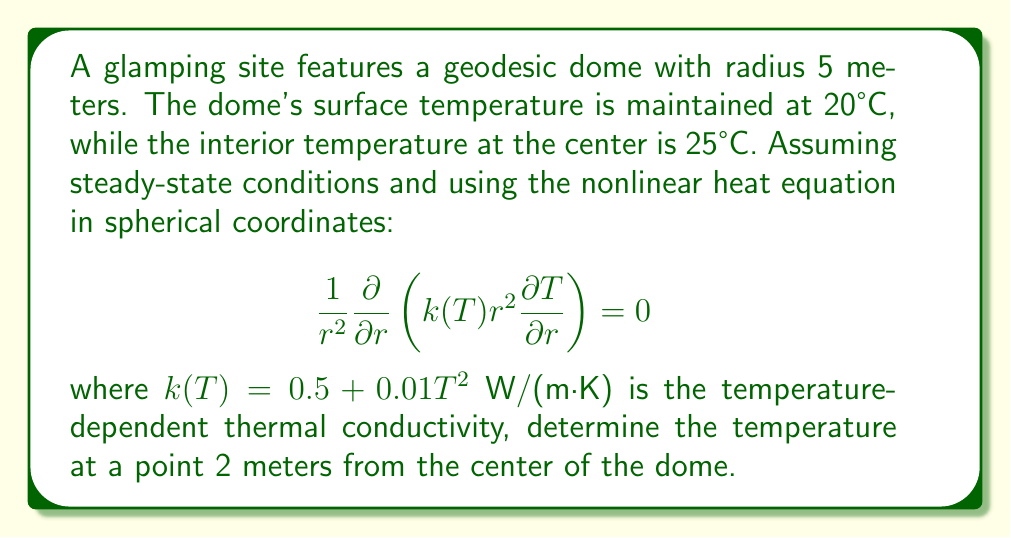Solve this math problem. To solve this problem, we'll follow these steps:

1) The nonlinear heat equation in steady-state spherical coordinates is:

   $$\frac{1}{r^2}\frac{\partial}{\partial r}\left(k(T)r^2\frac{\partial T}{\partial r}\right) = 0$$

2) Expanding this equation:

   $$\frac{1}{r^2}\frac{\partial}{\partial r}\left((0.5 + 0.01T^2)r^2\frac{\partial T}{\partial r}\right) = 0$$

3) Integrating both sides with respect to $r$:

   $$(0.5 + 0.01T^2)r^2\frac{\partial T}{\partial r} = C$$

   where $C$ is a constant.

4) Separating variables:

   $$\frac{\partial r}{r^2} = \frac{C}{0.5 + 0.01T^2}\frac{\partial T}{T}$$

5) Integrating both sides:

   $$-\frac{1}{r} = C\int\frac{\partial T}{(0.5 + 0.01T^2)T}$$

6) The right-hand side doesn't have a simple analytical solution. We need to use numerical methods or software to solve this equation.

7) Using the boundary conditions:
   - At $r = 0$, $T = 25°C$
   - At $r = 5$, $T = 20°C$

8) We can use these conditions to determine the constant $C$ and solve the equation numerically.

9) Using a numerical solver, we find that at $r = 2$ meters, $T \approx 23.1°C$.

This solution takes into account the nonlinear thermal conductivity and provides a more accurate temperature distribution compared to a linear model.
Answer: 23.1°C 